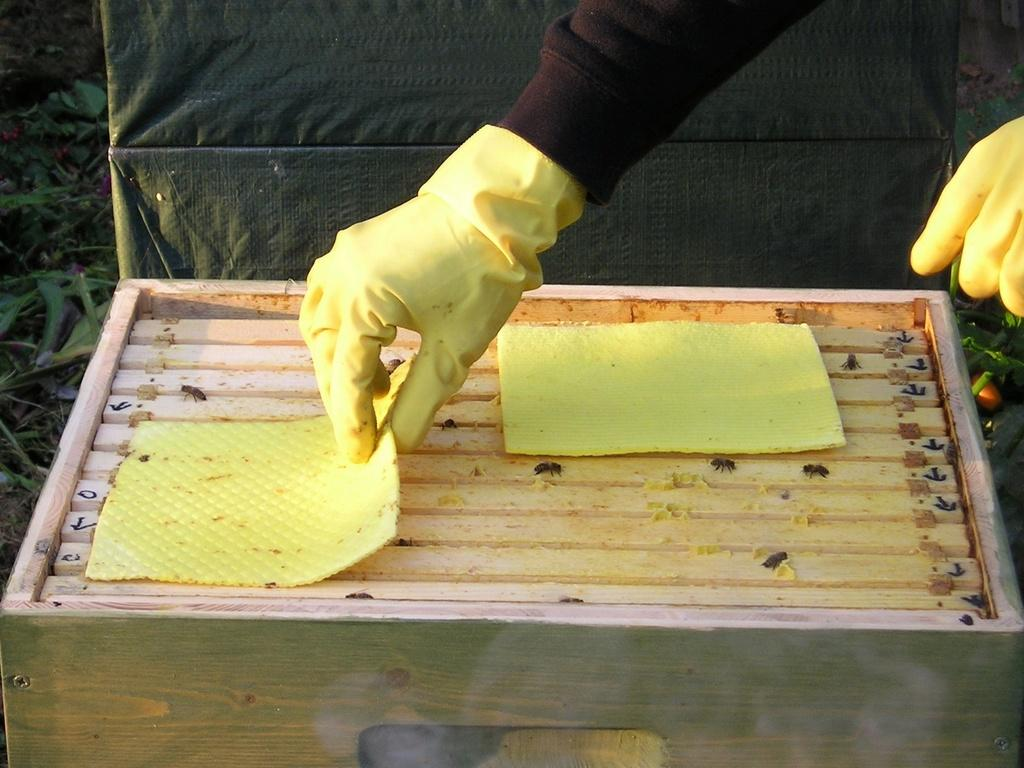What is on the box in the image? There are honey bees on the box. What color is the sheet on the box? The box has a yellow sheet. What is the person in the image wearing on their hands? The person is wearing gloves on their hands. What can be seen in the background of the image? There is a sheet and leaves in the background. What thoughts does the person in the image have about taking a bath? There is no information about the person's thoughts or a bath in the image. 